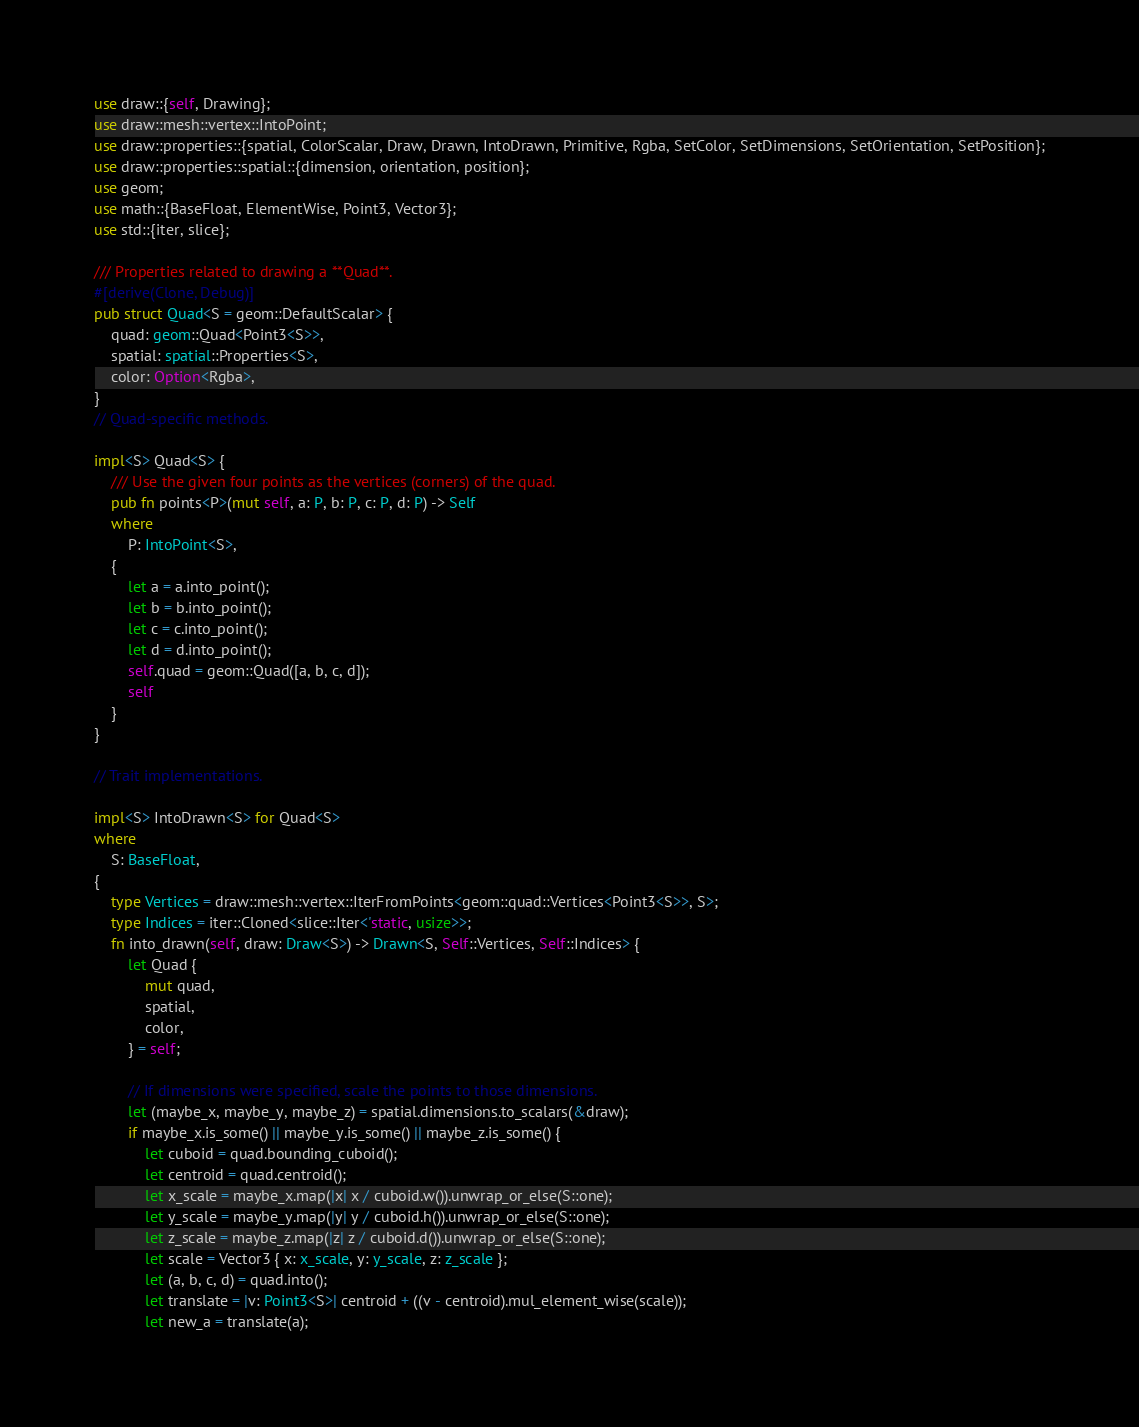Convert code to text. <code><loc_0><loc_0><loc_500><loc_500><_Rust_>use draw::{self, Drawing};
use draw::mesh::vertex::IntoPoint;
use draw::properties::{spatial, ColorScalar, Draw, Drawn, IntoDrawn, Primitive, Rgba, SetColor, SetDimensions, SetOrientation, SetPosition};
use draw::properties::spatial::{dimension, orientation, position};
use geom;
use math::{BaseFloat, ElementWise, Point3, Vector3};
use std::{iter, slice};

/// Properties related to drawing a **Quad**.
#[derive(Clone, Debug)]
pub struct Quad<S = geom::DefaultScalar> {
    quad: geom::Quad<Point3<S>>,
    spatial: spatial::Properties<S>,
    color: Option<Rgba>,
}
// Quad-specific methods.

impl<S> Quad<S> {
    /// Use the given four points as the vertices (corners) of the quad.
    pub fn points<P>(mut self, a: P, b: P, c: P, d: P) -> Self
    where
        P: IntoPoint<S>,
    {
        let a = a.into_point();
        let b = b.into_point();
        let c = c.into_point();
        let d = d.into_point();
        self.quad = geom::Quad([a, b, c, d]);
        self
    }
}

// Trait implementations.

impl<S> IntoDrawn<S> for Quad<S>
where
    S: BaseFloat,
{
    type Vertices = draw::mesh::vertex::IterFromPoints<geom::quad::Vertices<Point3<S>>, S>;
    type Indices = iter::Cloned<slice::Iter<'static, usize>>;
    fn into_drawn(self, draw: Draw<S>) -> Drawn<S, Self::Vertices, Self::Indices> {
        let Quad {
            mut quad,
            spatial,
            color,
        } = self;

        // If dimensions were specified, scale the points to those dimensions.
        let (maybe_x, maybe_y, maybe_z) = spatial.dimensions.to_scalars(&draw);
        if maybe_x.is_some() || maybe_y.is_some() || maybe_z.is_some() {
            let cuboid = quad.bounding_cuboid();
            let centroid = quad.centroid();
            let x_scale = maybe_x.map(|x| x / cuboid.w()).unwrap_or_else(S::one);
            let y_scale = maybe_y.map(|y| y / cuboid.h()).unwrap_or_else(S::one);
            let z_scale = maybe_z.map(|z| z / cuboid.d()).unwrap_or_else(S::one);
            let scale = Vector3 { x: x_scale, y: y_scale, z: z_scale };
            let (a, b, c, d) = quad.into();
            let translate = |v: Point3<S>| centroid + ((v - centroid).mul_element_wise(scale));
            let new_a = translate(a);</code> 